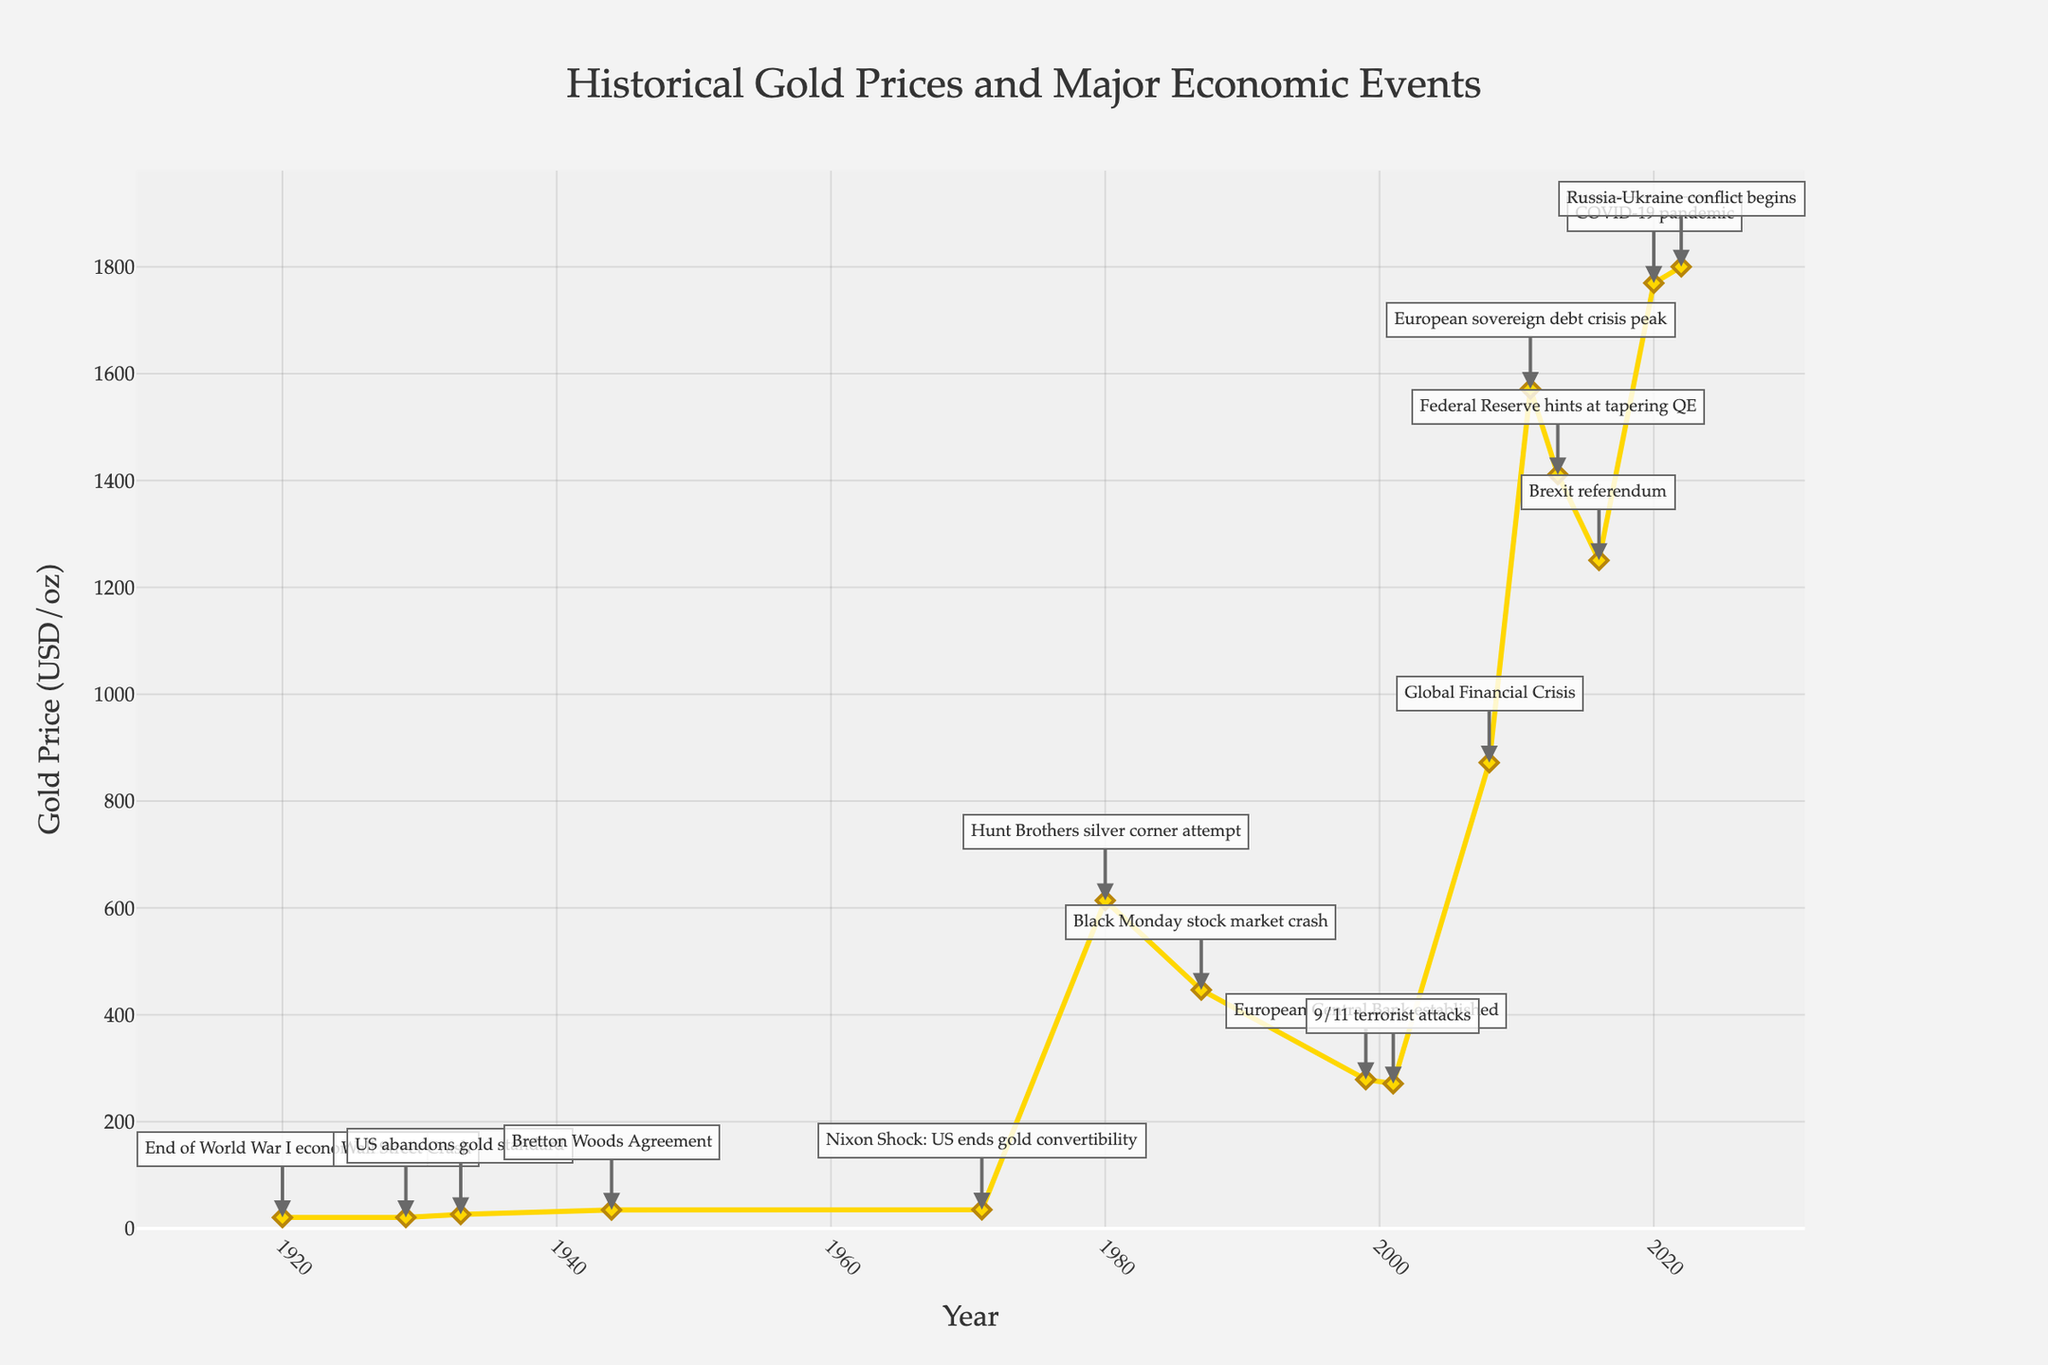what major economic event is marked at the 1920 data point? The chart has annotations for economic events at different points. In 1920, the event marked is "End of World War I economic effects."
Answer: End of World War I economic effects When did the US abandon the gold standard, and what was the gold price at that time? The chart shows that the US abandoned the gold standard in 1933, with the gold price at that time being $26.33 per ounce.
Answer: 1933, $26.33/oz During which year did the gold price peak between 1900 and 2022, and what was the price? Looking at the line chart, the highest peak in gold prices occurred in 2011, where the price reached $1571.52 per ounce.
Answer: 2011, $1571.52/oz Compare the gold prices during the Global Financial Crisis and the Brexit Referendum. Which was higher? The chart indicates that during the Global Financial Crisis (2008), the gold price was $871.96 per ounce. During the Brexit Referendum (2016), the price was $1250.74 per ounce. The price during the Brexit Referendum was higher.
Answer: Brexit Referendum, $1250.74/oz What is the difference in gold price from the year of the Wall Street Crash (1929) to the Bretton Woods Agreement (1944)? In 1929, the gold price was $20.63 per ounce, and in 1944, it was $34.71 per ounce. The difference is $34.71 - $20.63 = $14.08 per ounce.
Answer: $14.08/oz What visual clues denote significant economic events on the chart, and how are they represented? Significant economic events on the chart are represented by annotations with arrows pointing to the respective data points. Each annotation has a brief description of the event.
Answer: Annotations with arrows In which years did the gold price experience a sharp increase, according to the chart? The chart shows sharp increases in gold prices around 1980 during the Hunt Brothers silver corner attempt and around 2008 during the Global Financial Crisis.
Answer: 1980, 2008 How did the gold price change immediately following the Nixon Shock in 1971? Following the Nixon Shock in 1971, there is a noticeable increase in the gold price, rising significantly in subsequent years.
Answer: Increased Calculate the average gold price from 1920 to 1933 (End of WWI economic effects to US abandoning gold standard). Gold prices during this period were $20.68 (1920), $20.63 (1929), and $26.33 (1933). The average is calculated as ($20.68 + $20.63 + $26.33) / 3 = $22.55 per ounce.
Answer: $22.55/oz What was the gold price trend during the COVID-19 pandemic, and how does it compare to the price preceding it? The gold price during the COVID-19 pandemic (2020) was $1769.64 per ounce, which shows an increasing trend compared to $1250.74 per ounce during the Brexit Referendum (2016).
Answer: Increasing, higher than before 